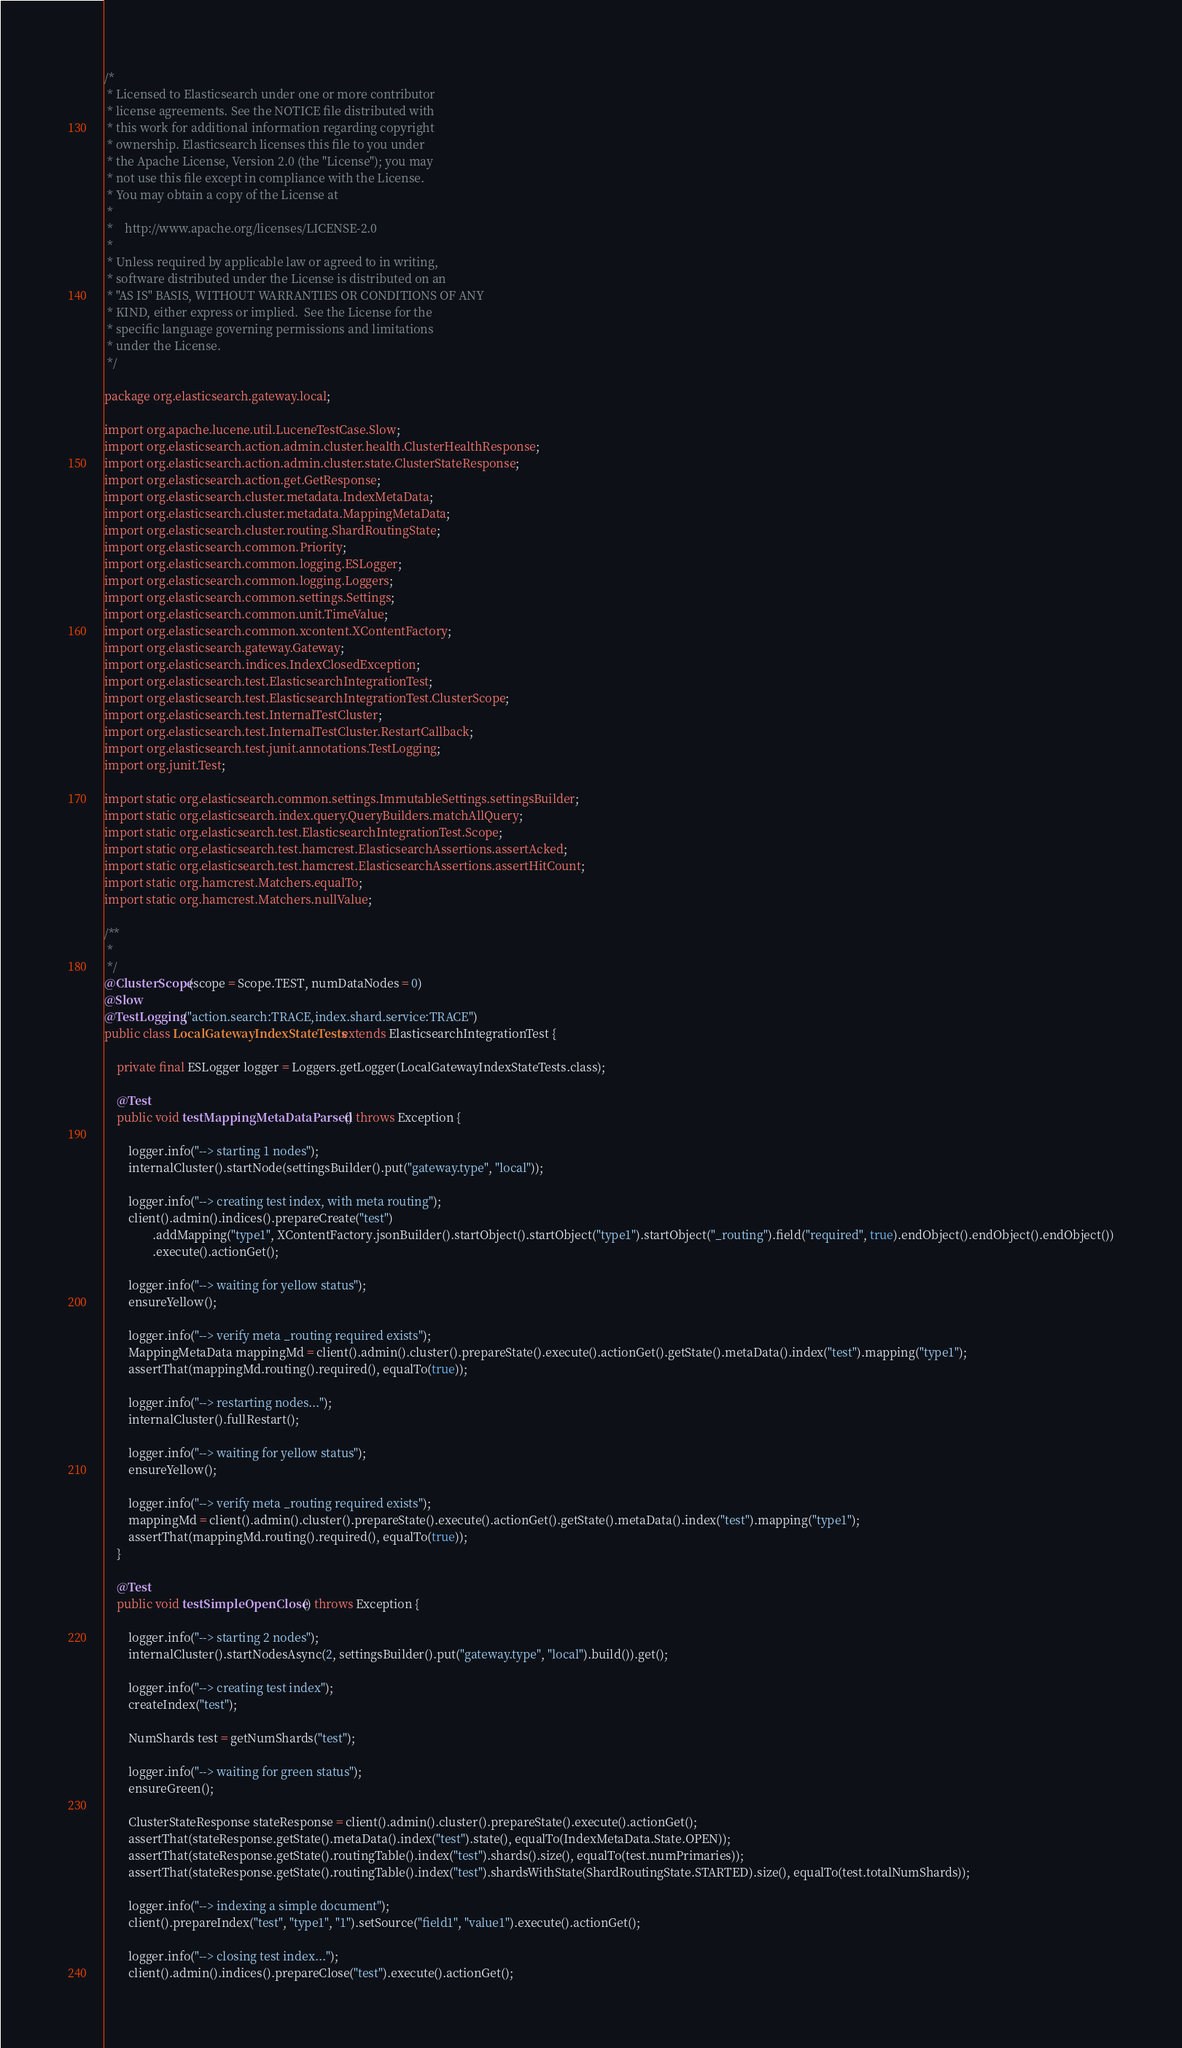<code> <loc_0><loc_0><loc_500><loc_500><_Java_>/*
 * Licensed to Elasticsearch under one or more contributor
 * license agreements. See the NOTICE file distributed with
 * this work for additional information regarding copyright
 * ownership. Elasticsearch licenses this file to you under
 * the Apache License, Version 2.0 (the "License"); you may
 * not use this file except in compliance with the License.
 * You may obtain a copy of the License at
 *
 *    http://www.apache.org/licenses/LICENSE-2.0
 *
 * Unless required by applicable law or agreed to in writing,
 * software distributed under the License is distributed on an
 * "AS IS" BASIS, WITHOUT WARRANTIES OR CONDITIONS OF ANY
 * KIND, either express or implied.  See the License for the
 * specific language governing permissions and limitations
 * under the License.
 */

package org.elasticsearch.gateway.local;

import org.apache.lucene.util.LuceneTestCase.Slow;
import org.elasticsearch.action.admin.cluster.health.ClusterHealthResponse;
import org.elasticsearch.action.admin.cluster.state.ClusterStateResponse;
import org.elasticsearch.action.get.GetResponse;
import org.elasticsearch.cluster.metadata.IndexMetaData;
import org.elasticsearch.cluster.metadata.MappingMetaData;
import org.elasticsearch.cluster.routing.ShardRoutingState;
import org.elasticsearch.common.Priority;
import org.elasticsearch.common.logging.ESLogger;
import org.elasticsearch.common.logging.Loggers;
import org.elasticsearch.common.settings.Settings;
import org.elasticsearch.common.unit.TimeValue;
import org.elasticsearch.common.xcontent.XContentFactory;
import org.elasticsearch.gateway.Gateway;
import org.elasticsearch.indices.IndexClosedException;
import org.elasticsearch.test.ElasticsearchIntegrationTest;
import org.elasticsearch.test.ElasticsearchIntegrationTest.ClusterScope;
import org.elasticsearch.test.InternalTestCluster;
import org.elasticsearch.test.InternalTestCluster.RestartCallback;
import org.elasticsearch.test.junit.annotations.TestLogging;
import org.junit.Test;

import static org.elasticsearch.common.settings.ImmutableSettings.settingsBuilder;
import static org.elasticsearch.index.query.QueryBuilders.matchAllQuery;
import static org.elasticsearch.test.ElasticsearchIntegrationTest.Scope;
import static org.elasticsearch.test.hamcrest.ElasticsearchAssertions.assertAcked;
import static org.elasticsearch.test.hamcrest.ElasticsearchAssertions.assertHitCount;
import static org.hamcrest.Matchers.equalTo;
import static org.hamcrest.Matchers.nullValue;

/**
 *
 */
@ClusterScope(scope = Scope.TEST, numDataNodes = 0)
@Slow
@TestLogging("action.search:TRACE,index.shard.service:TRACE")
public class LocalGatewayIndexStateTests extends ElasticsearchIntegrationTest {

    private final ESLogger logger = Loggers.getLogger(LocalGatewayIndexStateTests.class);

    @Test
    public void testMappingMetaDataParsed() throws Exception {

        logger.info("--> starting 1 nodes");
        internalCluster().startNode(settingsBuilder().put("gateway.type", "local"));

        logger.info("--> creating test index, with meta routing");
        client().admin().indices().prepareCreate("test")
                .addMapping("type1", XContentFactory.jsonBuilder().startObject().startObject("type1").startObject("_routing").field("required", true).endObject().endObject().endObject())
                .execute().actionGet();

        logger.info("--> waiting for yellow status");
        ensureYellow();

        logger.info("--> verify meta _routing required exists");
        MappingMetaData mappingMd = client().admin().cluster().prepareState().execute().actionGet().getState().metaData().index("test").mapping("type1");
        assertThat(mappingMd.routing().required(), equalTo(true));

        logger.info("--> restarting nodes...");
        internalCluster().fullRestart();

        logger.info("--> waiting for yellow status");
        ensureYellow();

        logger.info("--> verify meta _routing required exists");
        mappingMd = client().admin().cluster().prepareState().execute().actionGet().getState().metaData().index("test").mapping("type1");
        assertThat(mappingMd.routing().required(), equalTo(true));
    }

    @Test
    public void testSimpleOpenClose() throws Exception {

        logger.info("--> starting 2 nodes");
        internalCluster().startNodesAsync(2, settingsBuilder().put("gateway.type", "local").build()).get();

        logger.info("--> creating test index");
        createIndex("test");

        NumShards test = getNumShards("test");

        logger.info("--> waiting for green status");
        ensureGreen();

        ClusterStateResponse stateResponse = client().admin().cluster().prepareState().execute().actionGet();
        assertThat(stateResponse.getState().metaData().index("test").state(), equalTo(IndexMetaData.State.OPEN));
        assertThat(stateResponse.getState().routingTable().index("test").shards().size(), equalTo(test.numPrimaries));
        assertThat(stateResponse.getState().routingTable().index("test").shardsWithState(ShardRoutingState.STARTED).size(), equalTo(test.totalNumShards));

        logger.info("--> indexing a simple document");
        client().prepareIndex("test", "type1", "1").setSource("field1", "value1").execute().actionGet();

        logger.info("--> closing test index...");
        client().admin().indices().prepareClose("test").execute().actionGet();
</code> 